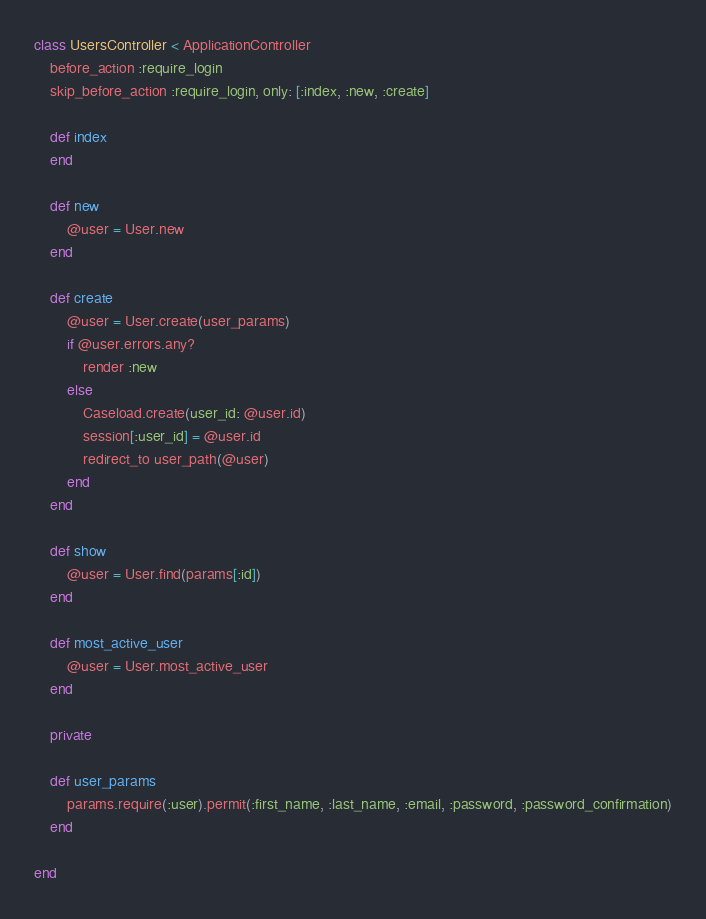Convert code to text. <code><loc_0><loc_0><loc_500><loc_500><_Ruby_>class UsersController < ApplicationController
    before_action :require_login
    skip_before_action :require_login, only: [:index, :new, :create]

    def index
    end

    def new
        @user = User.new
    end

    def create
        @user = User.create(user_params)
        if @user.errors.any?
            render :new
        else
            Caseload.create(user_id: @user.id)
            session[:user_id] = @user.id
            redirect_to user_path(@user)
        end
    end

    def show
        @user = User.find(params[:id])
    end

    def most_active_user
        @user = User.most_active_user
    end

    private

    def user_params
        params.require(:user).permit(:first_name, :last_name, :email, :password, :password_confirmation)
    end

end
</code> 